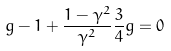<formula> <loc_0><loc_0><loc_500><loc_500>g - 1 + \frac { 1 - \gamma ^ { 2 } } { \gamma ^ { 2 } } \frac { 3 } { 4 } g = 0</formula> 